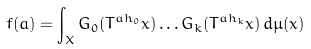<formula> <loc_0><loc_0><loc_500><loc_500>f ( a ) = \int _ { X } G _ { 0 } ( T ^ { a h _ { 0 } } x ) \dots G _ { k } ( T ^ { a h _ { k } } x ) \, d \mu ( x )</formula> 